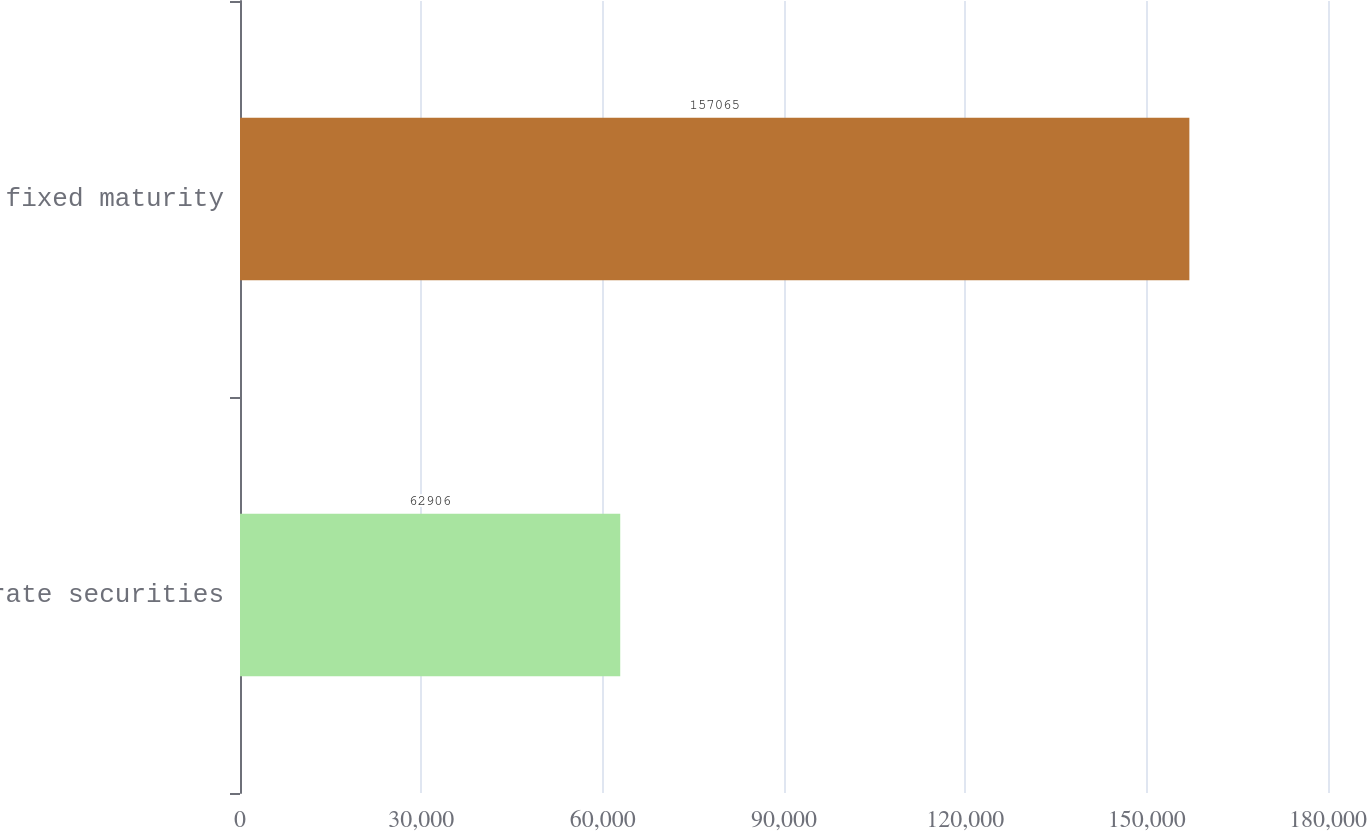Convert chart to OTSL. <chart><loc_0><loc_0><loc_500><loc_500><bar_chart><fcel>Corporate securities<fcel>Total fixed maturity<nl><fcel>62906<fcel>157065<nl></chart> 